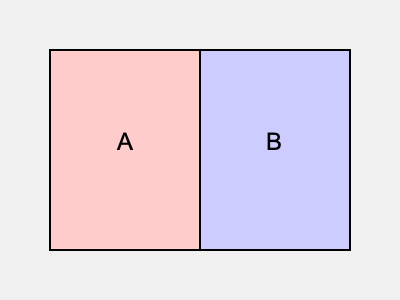In the simplified map of electoral districts shown above, if Andrea Letanovská's support is concentrated in district A, which type of redistricting strategy would you, as her opponent, advocate for to potentially reduce her influence? To answer this question, we need to consider the concept of gerrymandering and its potential impact on electoral outcomes. Here's a step-by-step explanation:

1. The map shows two districts, A and B, with equal areas.
2. Andrea Letanovská's support is concentrated in district A.
3. As her opponent, the goal would be to reduce her influence in the electoral process.
4. One strategy to achieve this is called "cracking," which involves splitting a strong voter base across multiple districts.
5. By redrawing the boundaries to divide district A into smaller parts and combining each part with areas from district B, Letanovská's support could be diluted.
6. This would potentially reduce her chances of winning in any single district, as her supporters would become minorities in multiple districts.
7. The opposite of cracking is "packing," which concentrates opposition voters into a few districts, but this would not be beneficial in this scenario.

Therefore, advocating for a redistricting strategy that implements cracking would be the most effective approach to potentially reduce Letanovská's influence.
Answer: Cracking 